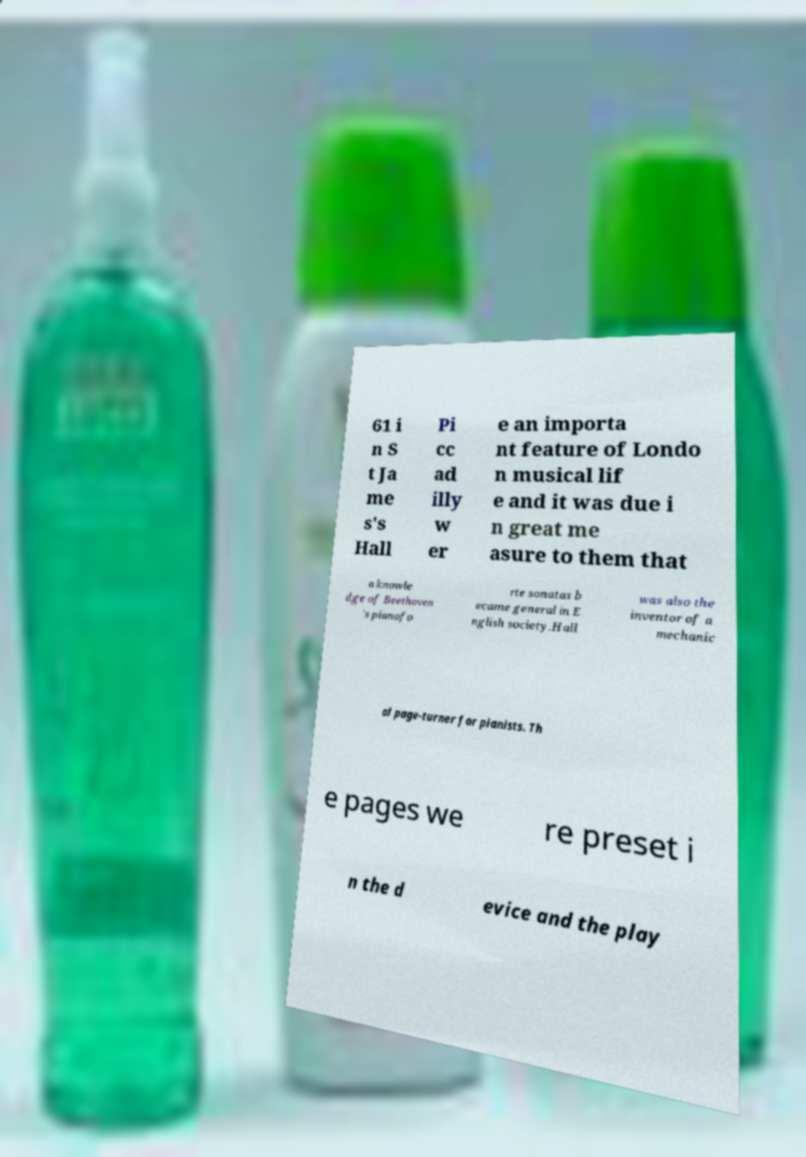Could you extract and type out the text from this image? 61 i n S t Ja me s's Hall Pi cc ad illy w er e an importa nt feature of Londo n musical lif e and it was due i n great me asure to them that a knowle dge of Beethoven 's pianofo rte sonatas b ecame general in E nglish society.Hall was also the inventor of a mechanic al page-turner for pianists. Th e pages we re preset i n the d evice and the play 